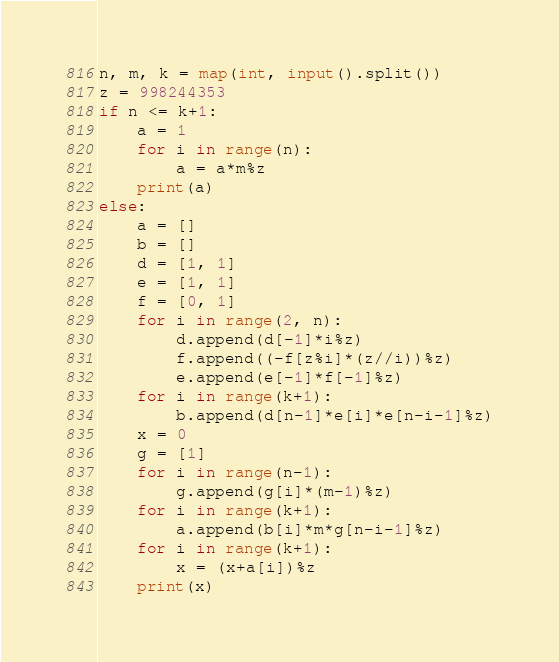Convert code to text. <code><loc_0><loc_0><loc_500><loc_500><_Python_>n, m, k = map(int, input().split())
z = 998244353
if n <= k+1:
    a = 1
    for i in range(n):
        a = a*m%z
    print(a)
else:
    a = []
    b = []
    d = [1, 1]
    e = [1, 1]
    f = [0, 1]
    for i in range(2, n):
        d.append(d[-1]*i%z)
        f.append((-f[z%i]*(z//i))%z)
        e.append(e[-1]*f[-1]%z)
    for i in range(k+1):
        b.append(d[n-1]*e[i]*e[n-i-1]%z)
    x = 0
    g = [1]
    for i in range(n-1):
        g.append(g[i]*(m-1)%z)
    for i in range(k+1):
        a.append(b[i]*m*g[n-i-1]%z)
    for i in range(k+1):
        x = (x+a[i])%z
    print(x)</code> 